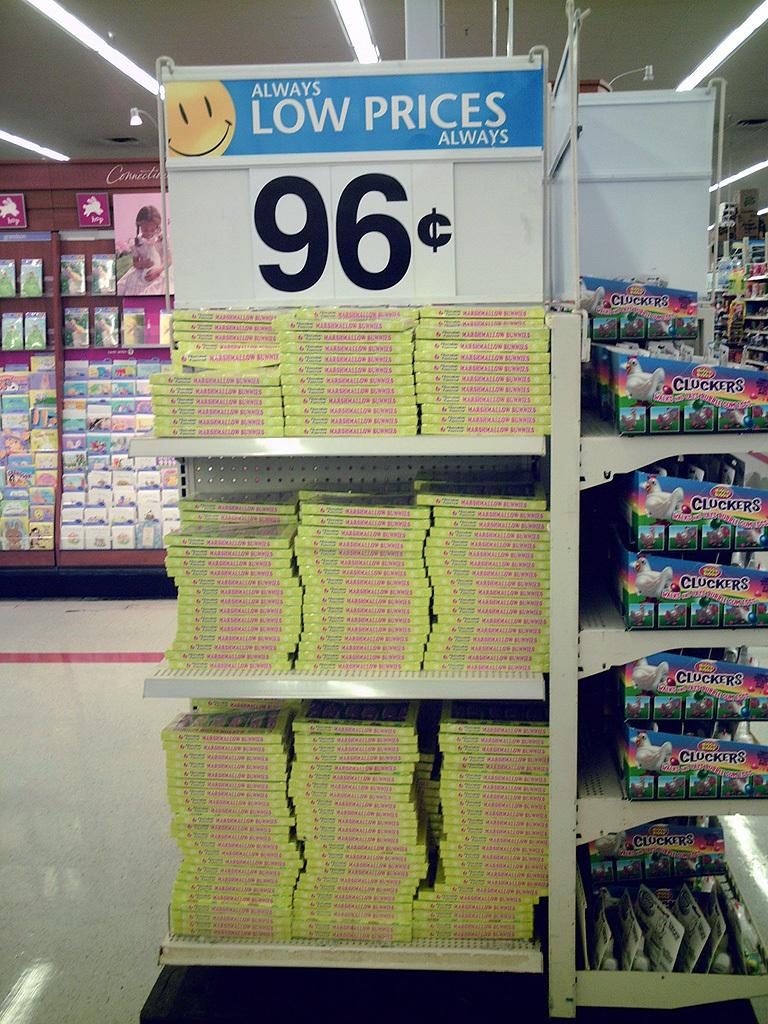<image>
Present a compact description of the photo's key features. a store shelf and a sign stating low prices 